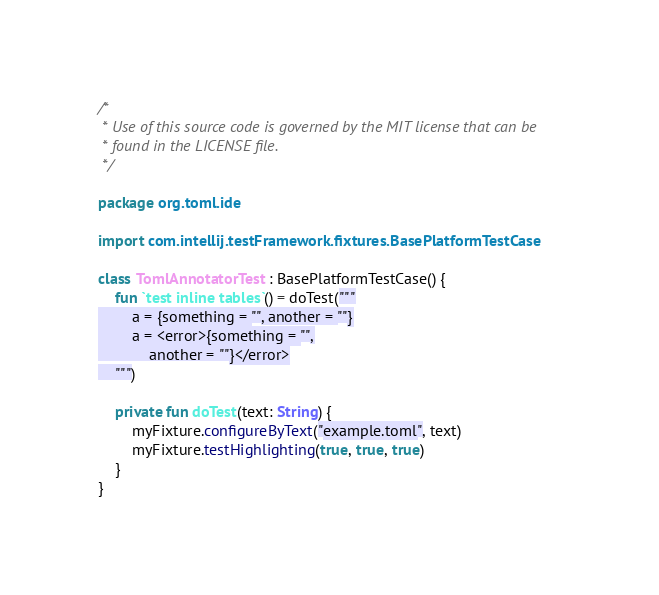<code> <loc_0><loc_0><loc_500><loc_500><_Kotlin_>/*
 * Use of this source code is governed by the MIT license that can be
 * found in the LICENSE file.
 */

package org.toml.ide

import com.intellij.testFramework.fixtures.BasePlatformTestCase

class TomlAnnotatorTest : BasePlatformTestCase() {
    fun `test inline tables`() = doTest("""
        a = {something = "", another = ""}
        a = <error>{something = "",
            another = ""}</error>
    """)

    private fun doTest(text: String) {
        myFixture.configureByText("example.toml", text)
        myFixture.testHighlighting(true, true, true)
    }
}
</code> 